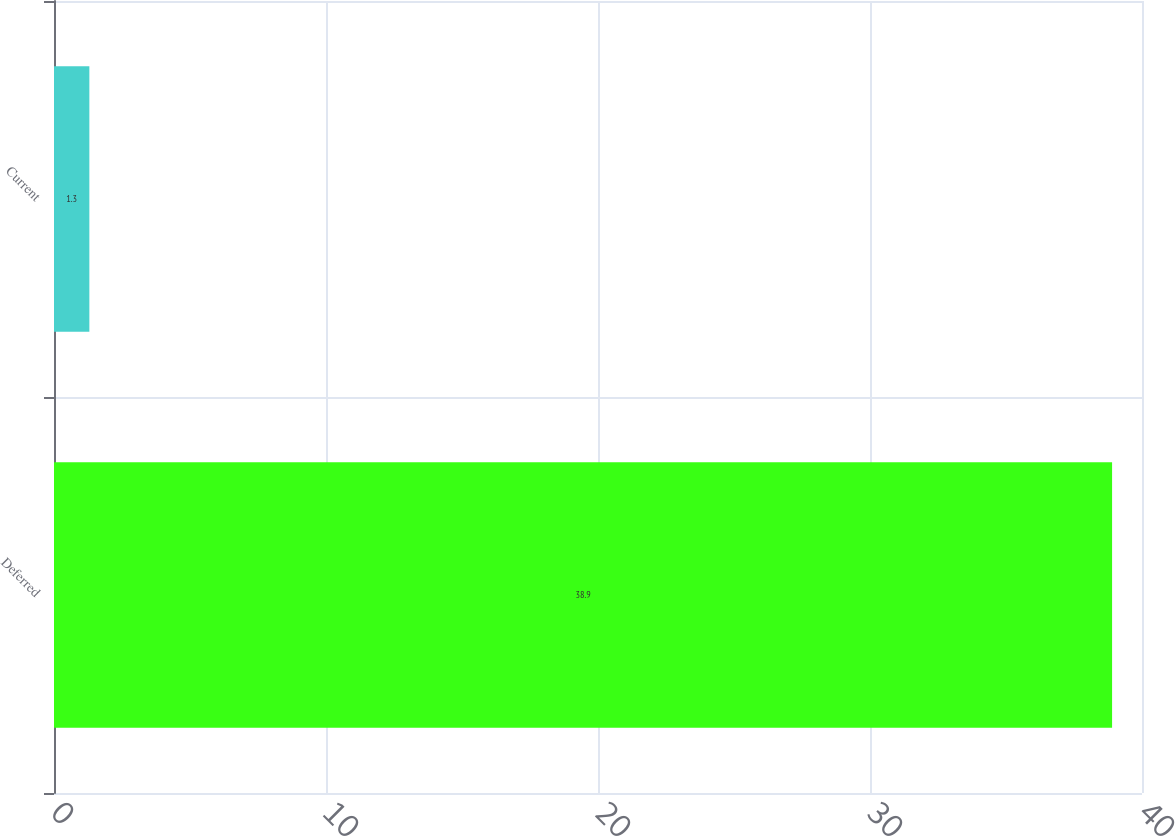Convert chart. <chart><loc_0><loc_0><loc_500><loc_500><bar_chart><fcel>Deferred<fcel>Current<nl><fcel>38.9<fcel>1.3<nl></chart> 